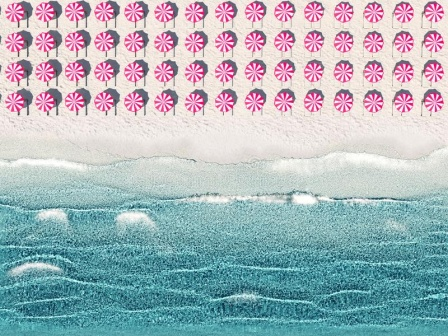Can you describe the beach scene in a more casual tone? Sure! The image shows a cool, artsy beach. There are these fun, pink and white candy-like shapes in the sky, making it look pretty dreamy. Beneath, the ocean is done in wavy blue lines with some white bits that look like foamy waves. The sandy beach at the bottom is this nice, light beige color, making the whole scene feel calm and summery. 